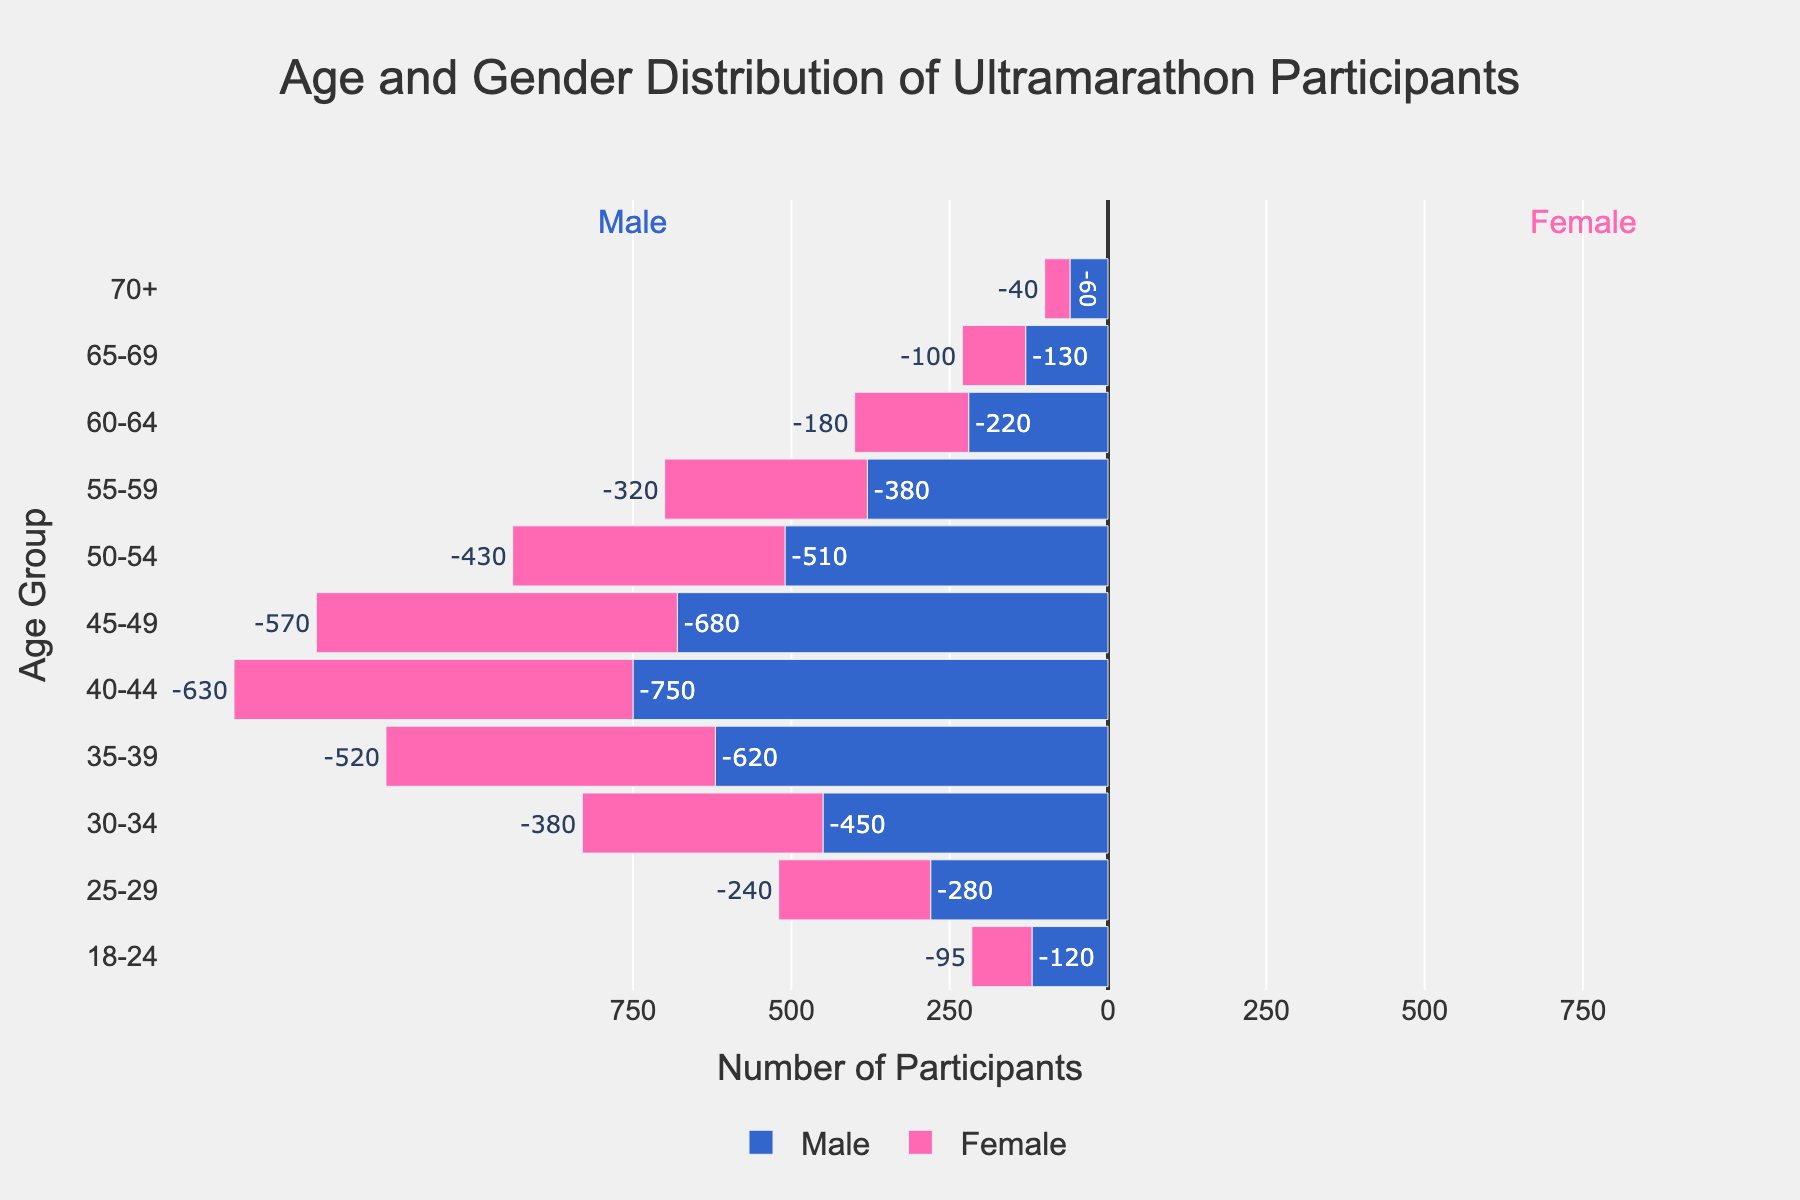How many male participants are there in the 35-39 age group? From the figure, locate the bar corresponding to males in the 35-39 age group. The value is given as 620 (note that it is negative to appear on the left side). Thus, the number of male participants is 620.
Answer: 620 What is the total number of female participants in the 40-44 age group? Find the bar representing females in the 40-44 age group on the right side of the pyramid. The value is 630, indicating there are 630 female participants.
Answer: 630 Which age group has the largest number of male participants? Identify which bar on the left side of the pyramid (representing males) extends the farthest. The 40-44 age group has the longest bar with a value of 750.
Answer: 40-44 What is the difference between male and female participants in the 30-34 age group? The number of male participants in the 30-34 age group is 450, and the number of female participants is 380. The difference is calculated as 450 - 380 = 70.
Answer: 70 What is the sum of male and female participants in the 50-54 age group? The number of male participants is 510, and female participants are 430. Summing these gives 510 + 430 = 940.
Answer: 940 Which gender is more heavily represented in the age group of 60-64? Compare the length of the bars for males and females in the 60-64 age group. Males have 220 participants, and females have 180. Males are more represented.
Answer: Males How does the number of female participants in the 18-24 age group compare to the number in the 70+ age group? The bar for females in the 18-24 age group is 95, and for the 70+ age group is 40. Comparing these, 95 is greater than 40.
Answer: 18-24 What is the average number of participants per age group for males? Sum all the male participants: 120+280+450+620+750+680+510+380+220+130+60 = 4200. There are 11 age groups. The average is 4200/11 ≈ 382.
Answer: 382 How does the distribution of male participants compare to female participants overall? Observing the lengths of bars on both sides, we can see that bars on the left (males) are generally longer than those on the right (females), indicating more male participants in most age groups.
Answer: More males Is there a notable age group where the number of male and female participants is almost equal? Compare the lengths of the bars of each age group for males and females. The 50-54 age group has 510 males and 430 females, the closest difference.
Answer: 50-54 